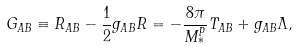<formula> <loc_0><loc_0><loc_500><loc_500>G _ { A B } \equiv R _ { A B } - \frac { 1 } { 2 } g _ { A B } R = - \frac { 8 \pi } { M ^ { p } _ { * } } T _ { A B } + g _ { A B } \Lambda ,</formula> 